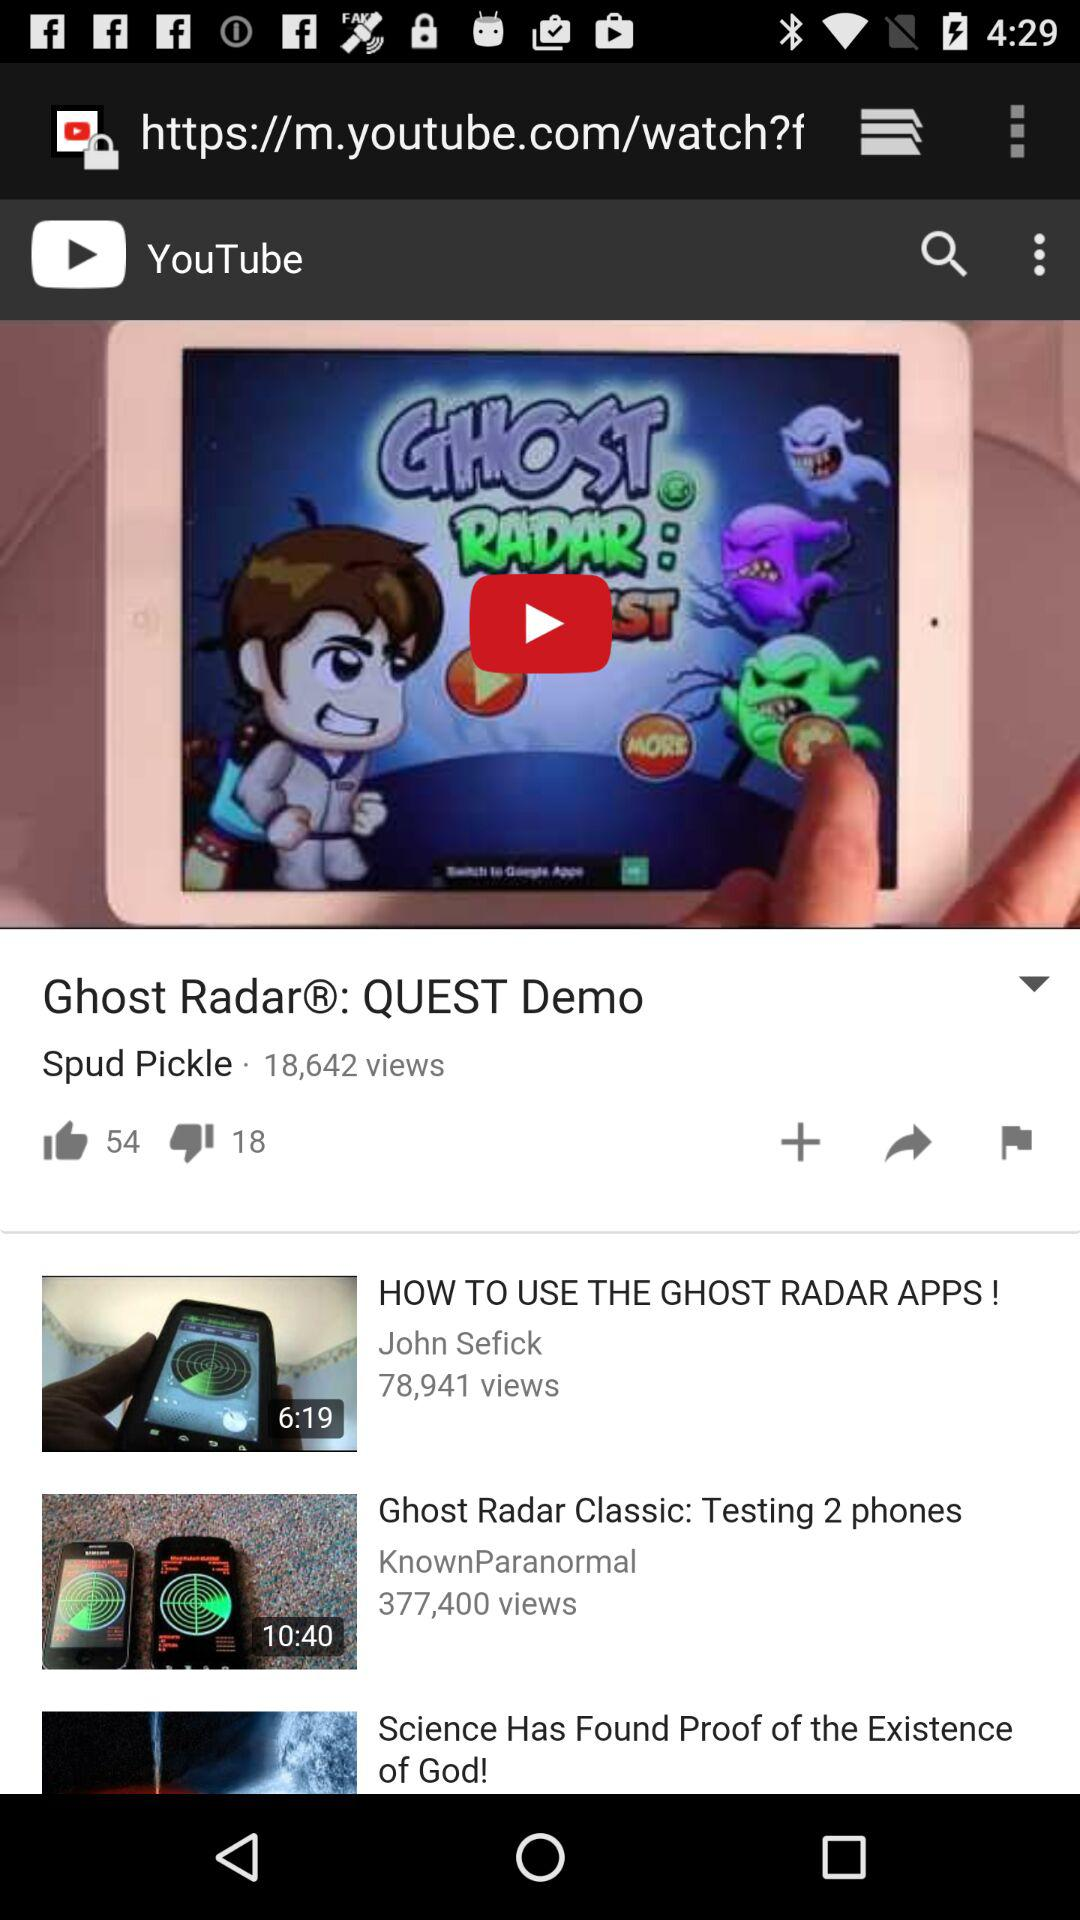How many likes are on the "Ghost Radar®: QUEST Demo"? There are 54 likes. 